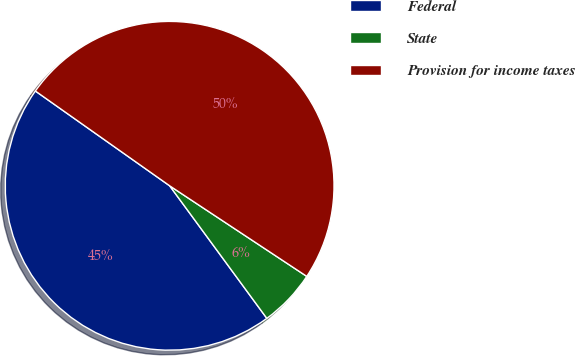Convert chart. <chart><loc_0><loc_0><loc_500><loc_500><pie_chart><fcel>Federal<fcel>State<fcel>Provision for income taxes<nl><fcel>44.85%<fcel>5.64%<fcel>49.51%<nl></chart> 